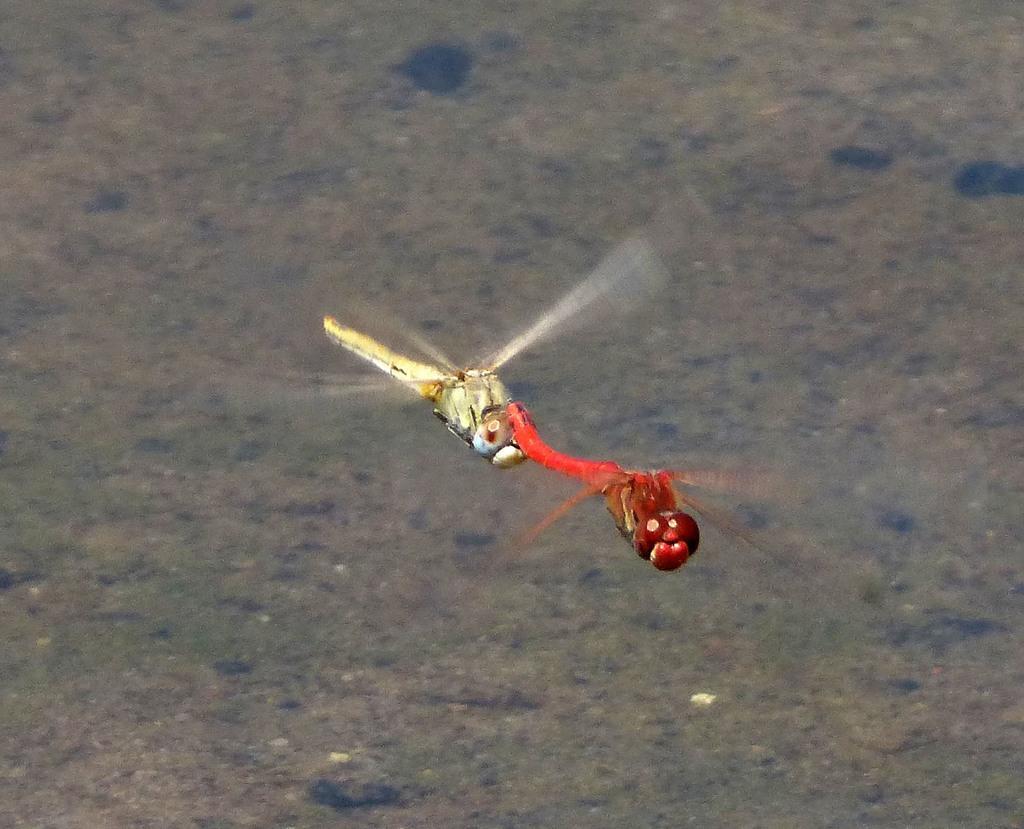In one or two sentences, can you explain what this image depicts? In this image, we can see some dragonflies. We can also see the background. 